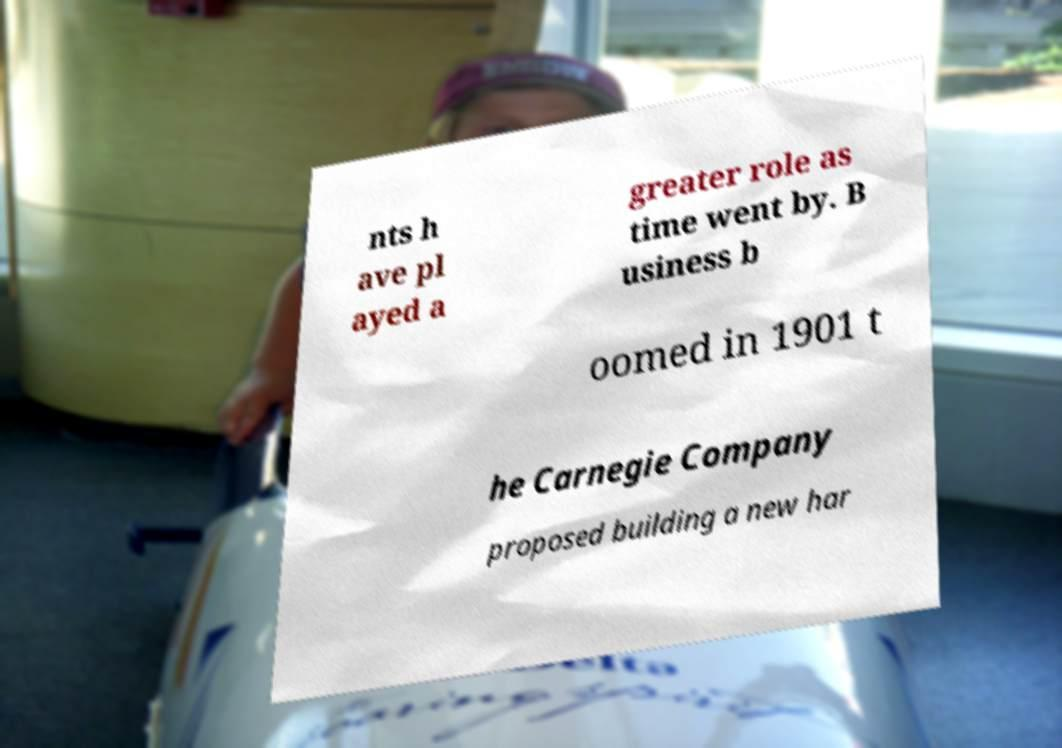Can you accurately transcribe the text from the provided image for me? nts h ave pl ayed a greater role as time went by. B usiness b oomed in 1901 t he Carnegie Company proposed building a new har 